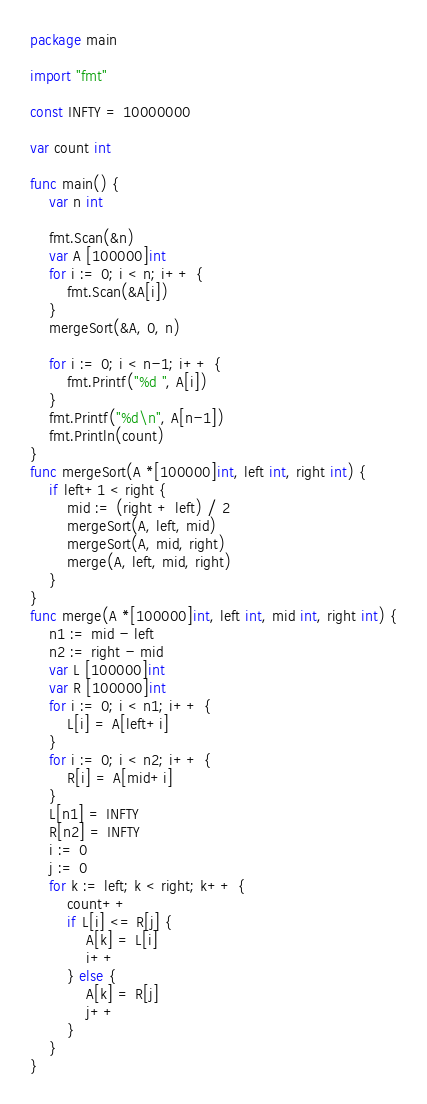Convert code to text. <code><loc_0><loc_0><loc_500><loc_500><_Go_>package main

import "fmt"

const INFTY = 10000000

var count int

func main() {
	var n int

	fmt.Scan(&n)
	var A [100000]int
	for i := 0; i < n; i++ {
		fmt.Scan(&A[i])
	}
	mergeSort(&A, 0, n)

	for i := 0; i < n-1; i++ {
		fmt.Printf("%d ", A[i])
	}
	fmt.Printf("%d\n", A[n-1])
	fmt.Println(count)
}
func mergeSort(A *[100000]int, left int, right int) {
	if left+1 < right {
		mid := (right + left) / 2
		mergeSort(A, left, mid)
		mergeSort(A, mid, right)
		merge(A, left, mid, right)
	}
}
func merge(A *[100000]int, left int, mid int, right int) {
	n1 := mid - left
	n2 := right - mid
	var L [100000]int
	var R [100000]int
	for i := 0; i < n1; i++ {
		L[i] = A[left+i]
	}
	for i := 0; i < n2; i++ {
		R[i] = A[mid+i]
	}
	L[n1] = INFTY
	R[n2] = INFTY
	i := 0
	j := 0
	for k := left; k < right; k++ {
		count++
		if L[i] <= R[j] {
			A[k] = L[i]
			i++
		} else {
			A[k] = R[j]
			j++
		}
	}
}

</code> 